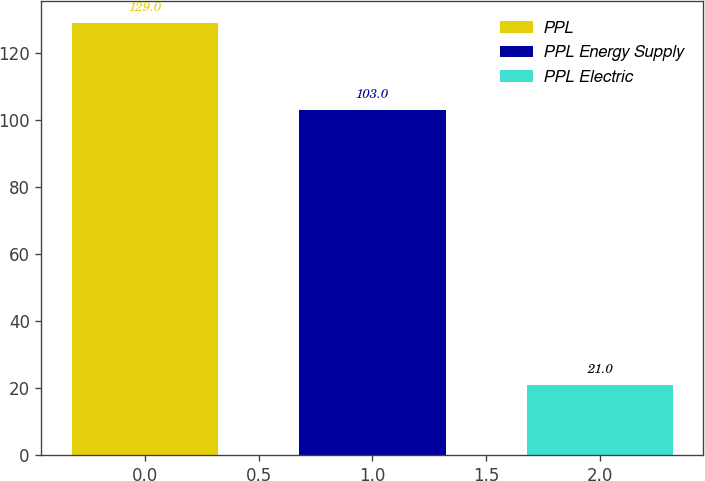Convert chart. <chart><loc_0><loc_0><loc_500><loc_500><bar_chart><fcel>PPL<fcel>PPL Energy Supply<fcel>PPL Electric<nl><fcel>129<fcel>103<fcel>21<nl></chart> 